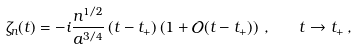Convert formula to latex. <formula><loc_0><loc_0><loc_500><loc_500>\zeta _ { n } ( t ) = - i \frac { n ^ { 1 / 2 } } { a ^ { 3 / 4 } } \, ( t - t _ { + } ) \left ( 1 + \mathcal { O } ( t - t _ { + } ) \right ) \, , \quad t \to t _ { + } \, ,</formula> 